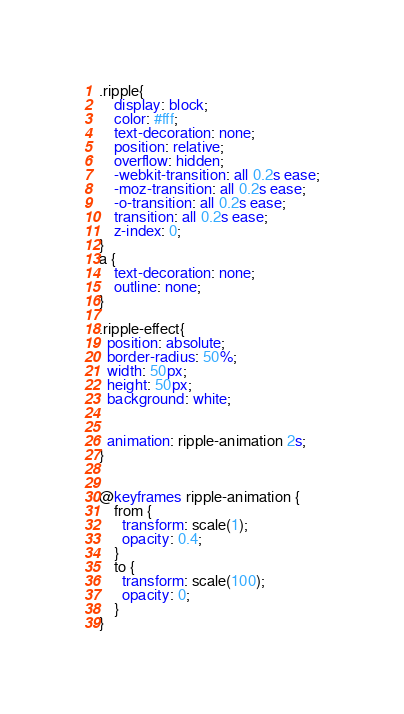Convert code to text. <code><loc_0><loc_0><loc_500><loc_500><_CSS_>.ripple{
    display: block;
    color: #fff;
    text-decoration: none;
    position: relative;
    overflow: hidden;
    -webkit-transition: all 0.2s ease;
    -moz-transition: all 0.2s ease;
    -o-transition: all 0.2s ease;
    transition: all 0.2s ease;
    z-index: 0;
}
a {
    text-decoration: none;
    outline: none;
}

.ripple-effect{
  position: absolute;
  border-radius: 50%;
  width: 50px;
  height: 50px;
  background: white;

    
  animation: ripple-animation 2s;
}


@keyframes ripple-animation {
    from {
      transform: scale(1);
      opacity: 0.4;
    }
    to {
      transform: scale(100);
      opacity: 0;
    }
}</code> 